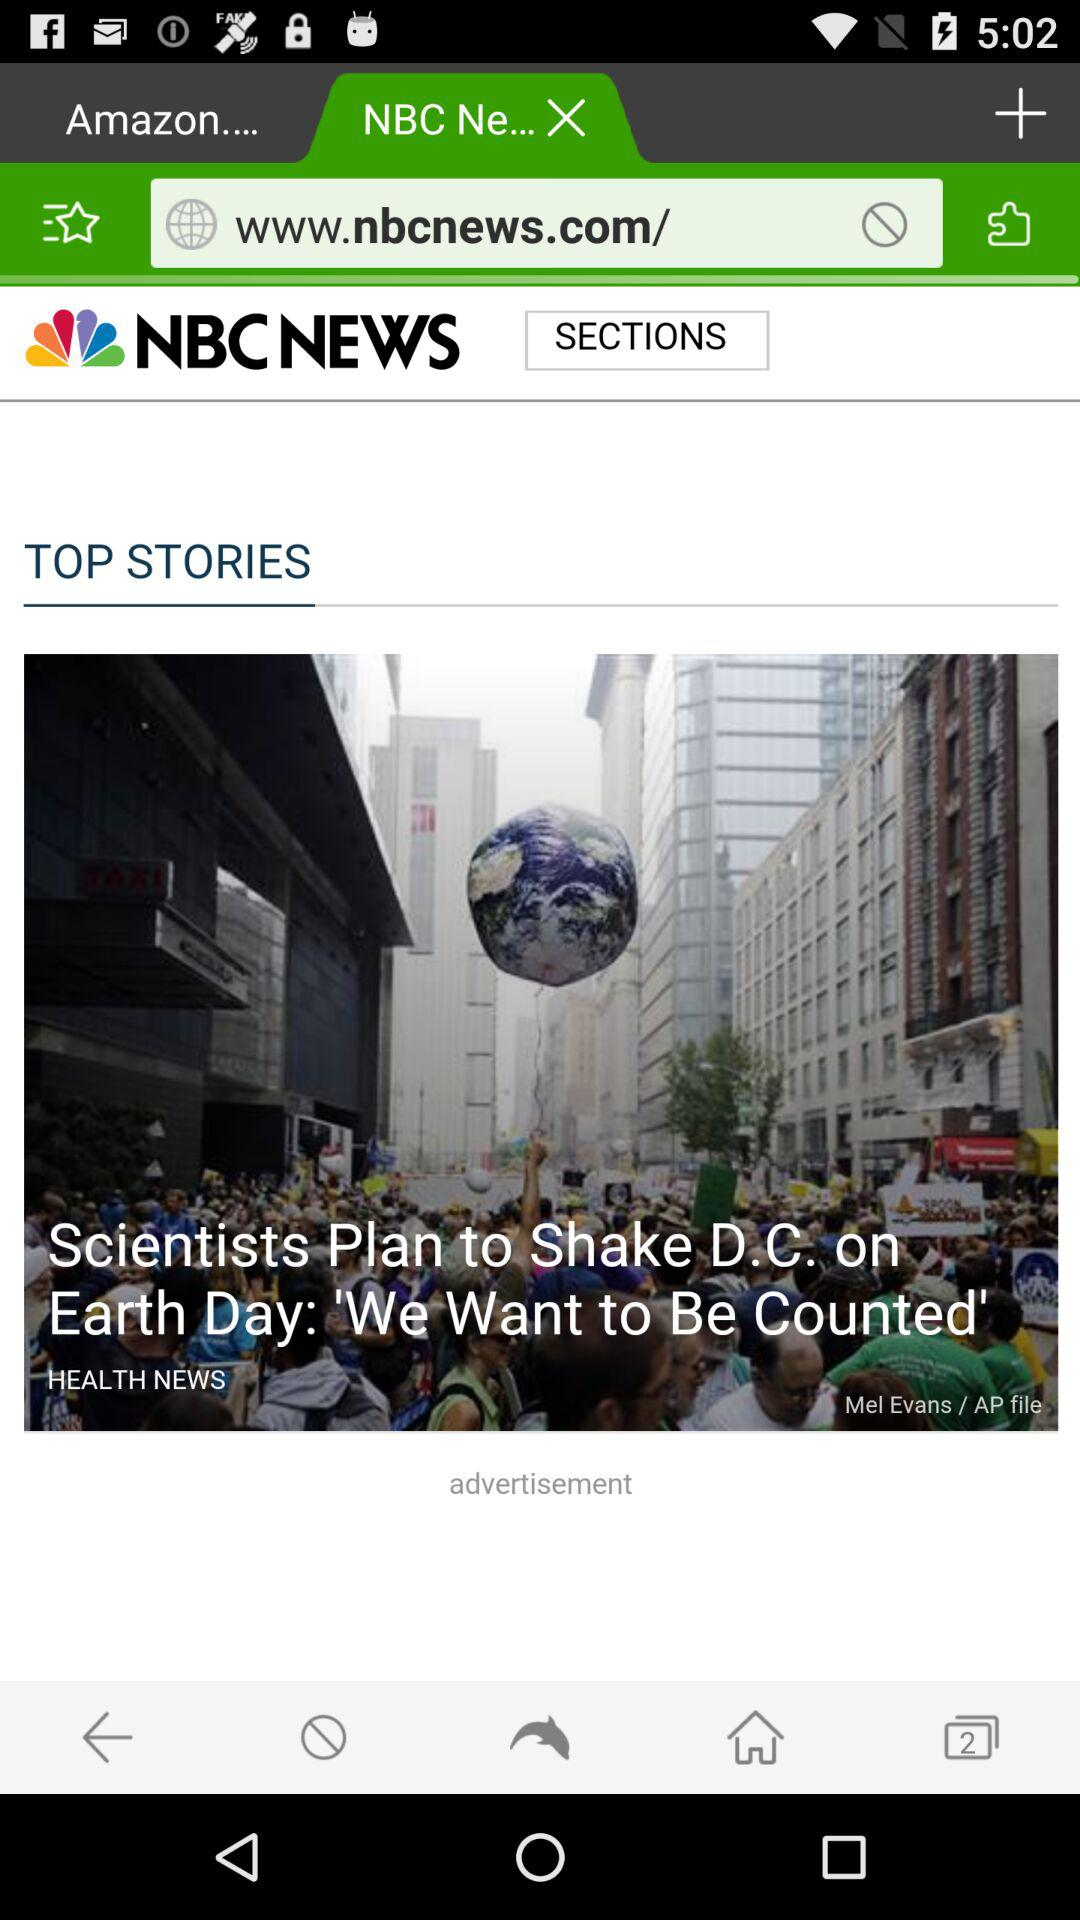What news channel has posted this article? This article was posted by NBC News. 